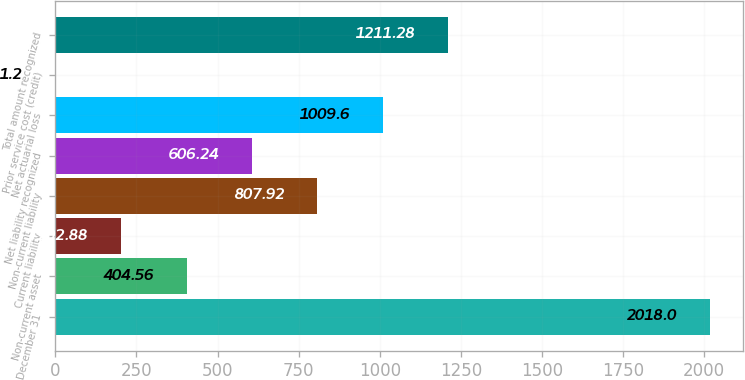Convert chart to OTSL. <chart><loc_0><loc_0><loc_500><loc_500><bar_chart><fcel>December 31<fcel>Non-current asset<fcel>Current liability<fcel>Non-current liability<fcel>Net liability recognized<fcel>Net actuarial loss<fcel>Prior service cost (credit)<fcel>Total amount recognized<nl><fcel>2018<fcel>404.56<fcel>202.88<fcel>807.92<fcel>606.24<fcel>1009.6<fcel>1.2<fcel>1211.28<nl></chart> 